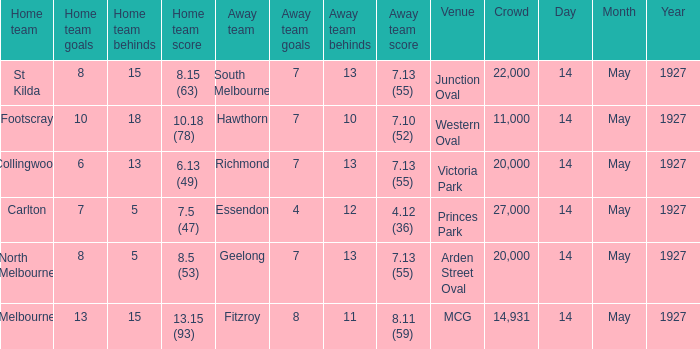How much is the sum of every crowd in attendance when the away score was 7.13 (55) for Richmond? 20000.0. 